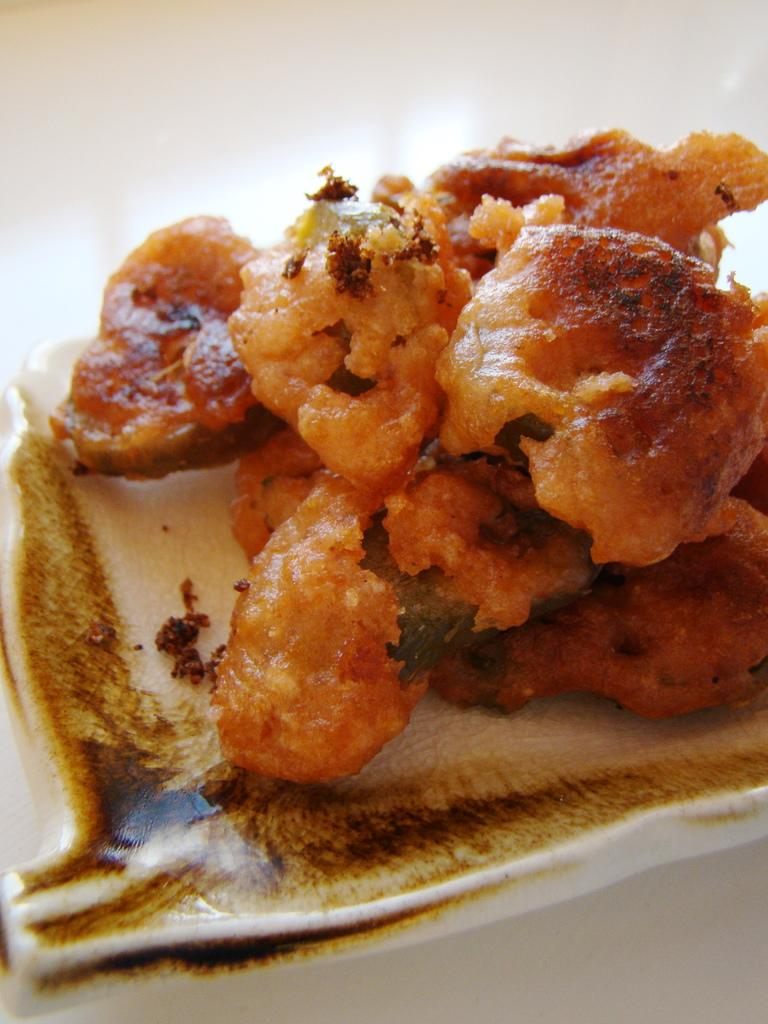What is on the plate that is visible in the image? There is food in a plate in the image. What color is the background of the image? The background of the image is white. Where is the vase located in the image? There is no vase present in the image. What type of crate is visible in the image? There is no crate present in the image. What kind of beam can be seen supporting the ceiling in the image? There is no beam present in the image. 